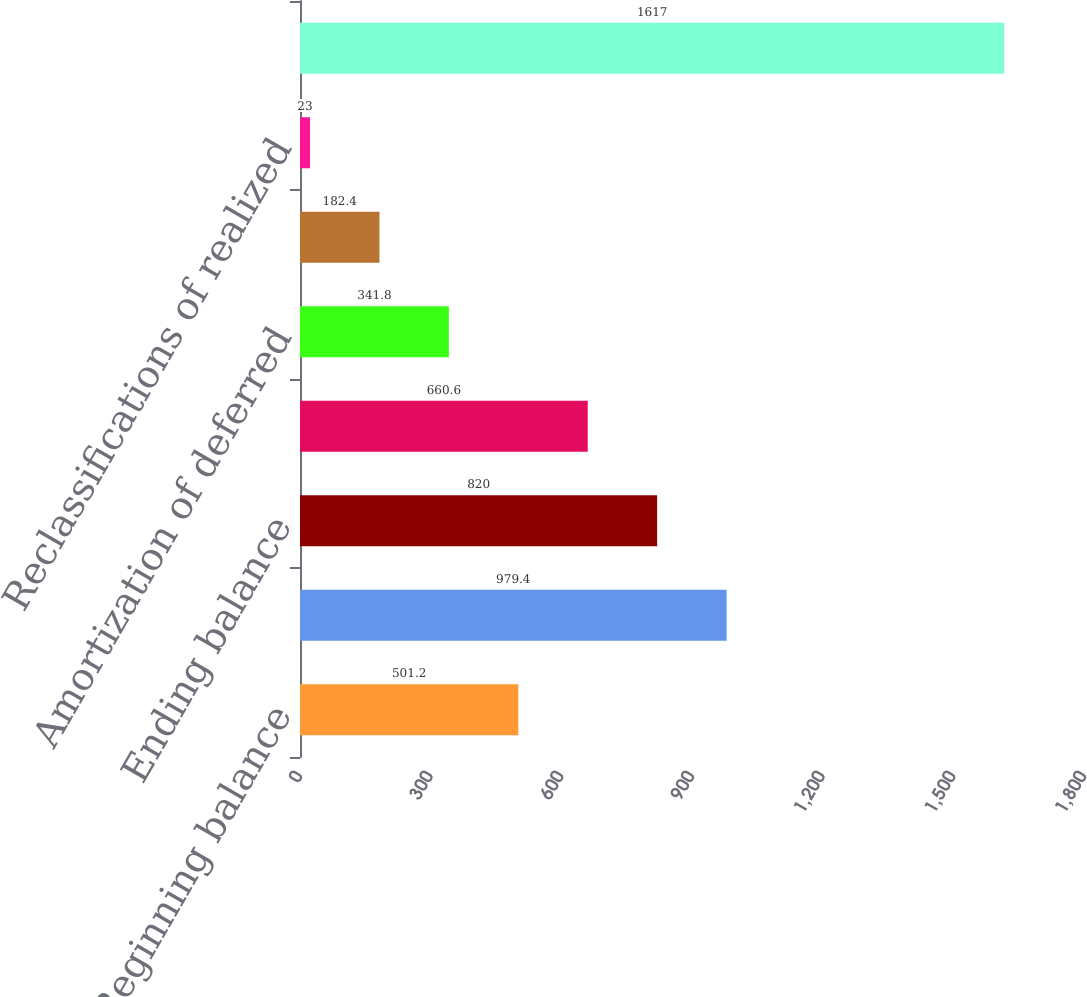Convert chart. <chart><loc_0><loc_0><loc_500><loc_500><bar_chart><fcel>Beginning balance<fcel>Other comprehensive income<fcel>Ending balance<fcel>Actuarial gains (losses)<fcel>Amortization of deferred<fcel>Gains (Losses) deferred during<fcel>Reclassifications of realized<fcel>Accumulated other<nl><fcel>501.2<fcel>979.4<fcel>820<fcel>660.6<fcel>341.8<fcel>182.4<fcel>23<fcel>1617<nl></chart> 